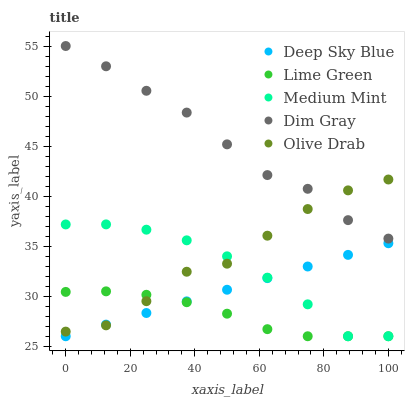Does Lime Green have the minimum area under the curve?
Answer yes or no. Yes. Does Dim Gray have the maximum area under the curve?
Answer yes or no. Yes. Does Dim Gray have the minimum area under the curve?
Answer yes or no. No. Does Lime Green have the maximum area under the curve?
Answer yes or no. No. Is Deep Sky Blue the smoothest?
Answer yes or no. Yes. Is Olive Drab the roughest?
Answer yes or no. Yes. Is Dim Gray the smoothest?
Answer yes or no. No. Is Dim Gray the roughest?
Answer yes or no. No. Does Medium Mint have the lowest value?
Answer yes or no. Yes. Does Dim Gray have the lowest value?
Answer yes or no. No. Does Dim Gray have the highest value?
Answer yes or no. Yes. Does Lime Green have the highest value?
Answer yes or no. No. Is Lime Green less than Dim Gray?
Answer yes or no. Yes. Is Dim Gray greater than Medium Mint?
Answer yes or no. Yes. Does Lime Green intersect Deep Sky Blue?
Answer yes or no. Yes. Is Lime Green less than Deep Sky Blue?
Answer yes or no. No. Is Lime Green greater than Deep Sky Blue?
Answer yes or no. No. Does Lime Green intersect Dim Gray?
Answer yes or no. No. 